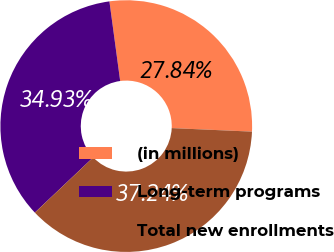Convert chart. <chart><loc_0><loc_0><loc_500><loc_500><pie_chart><fcel>(in millions)<fcel>Long-term programs<fcel>Total new enrollments<nl><fcel>27.84%<fcel>34.93%<fcel>37.24%<nl></chart> 